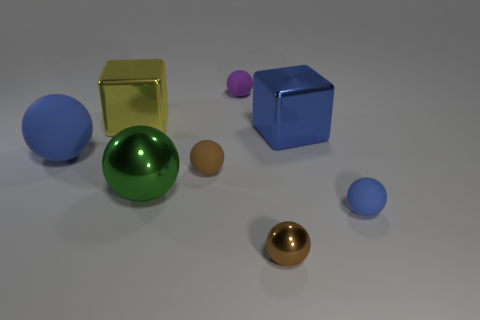What is the size of the purple rubber object that is the same shape as the large green thing?
Keep it short and to the point. Small. How many big spheres are made of the same material as the large green thing?
Provide a succinct answer. 0. Does the big rubber ball have the same color as the tiny matte thing in front of the large green object?
Give a very brief answer. Yes. Is the number of metal blocks greater than the number of objects?
Give a very brief answer. No. What is the color of the tiny metallic object?
Your response must be concise. Brown. Do the rubber ball on the right side of the tiny purple thing and the large rubber thing have the same color?
Your response must be concise. Yes. There is a sphere that is the same color as the small metal thing; what material is it?
Provide a succinct answer. Rubber. What number of other large balls are the same color as the big rubber ball?
Offer a terse response. 0. Does the brown thing that is in front of the small blue object have the same shape as the purple rubber thing?
Your answer should be very brief. Yes. Are there fewer large metal cubes that are in front of the big yellow metal block than rubber balls behind the green ball?
Provide a short and direct response. Yes. 